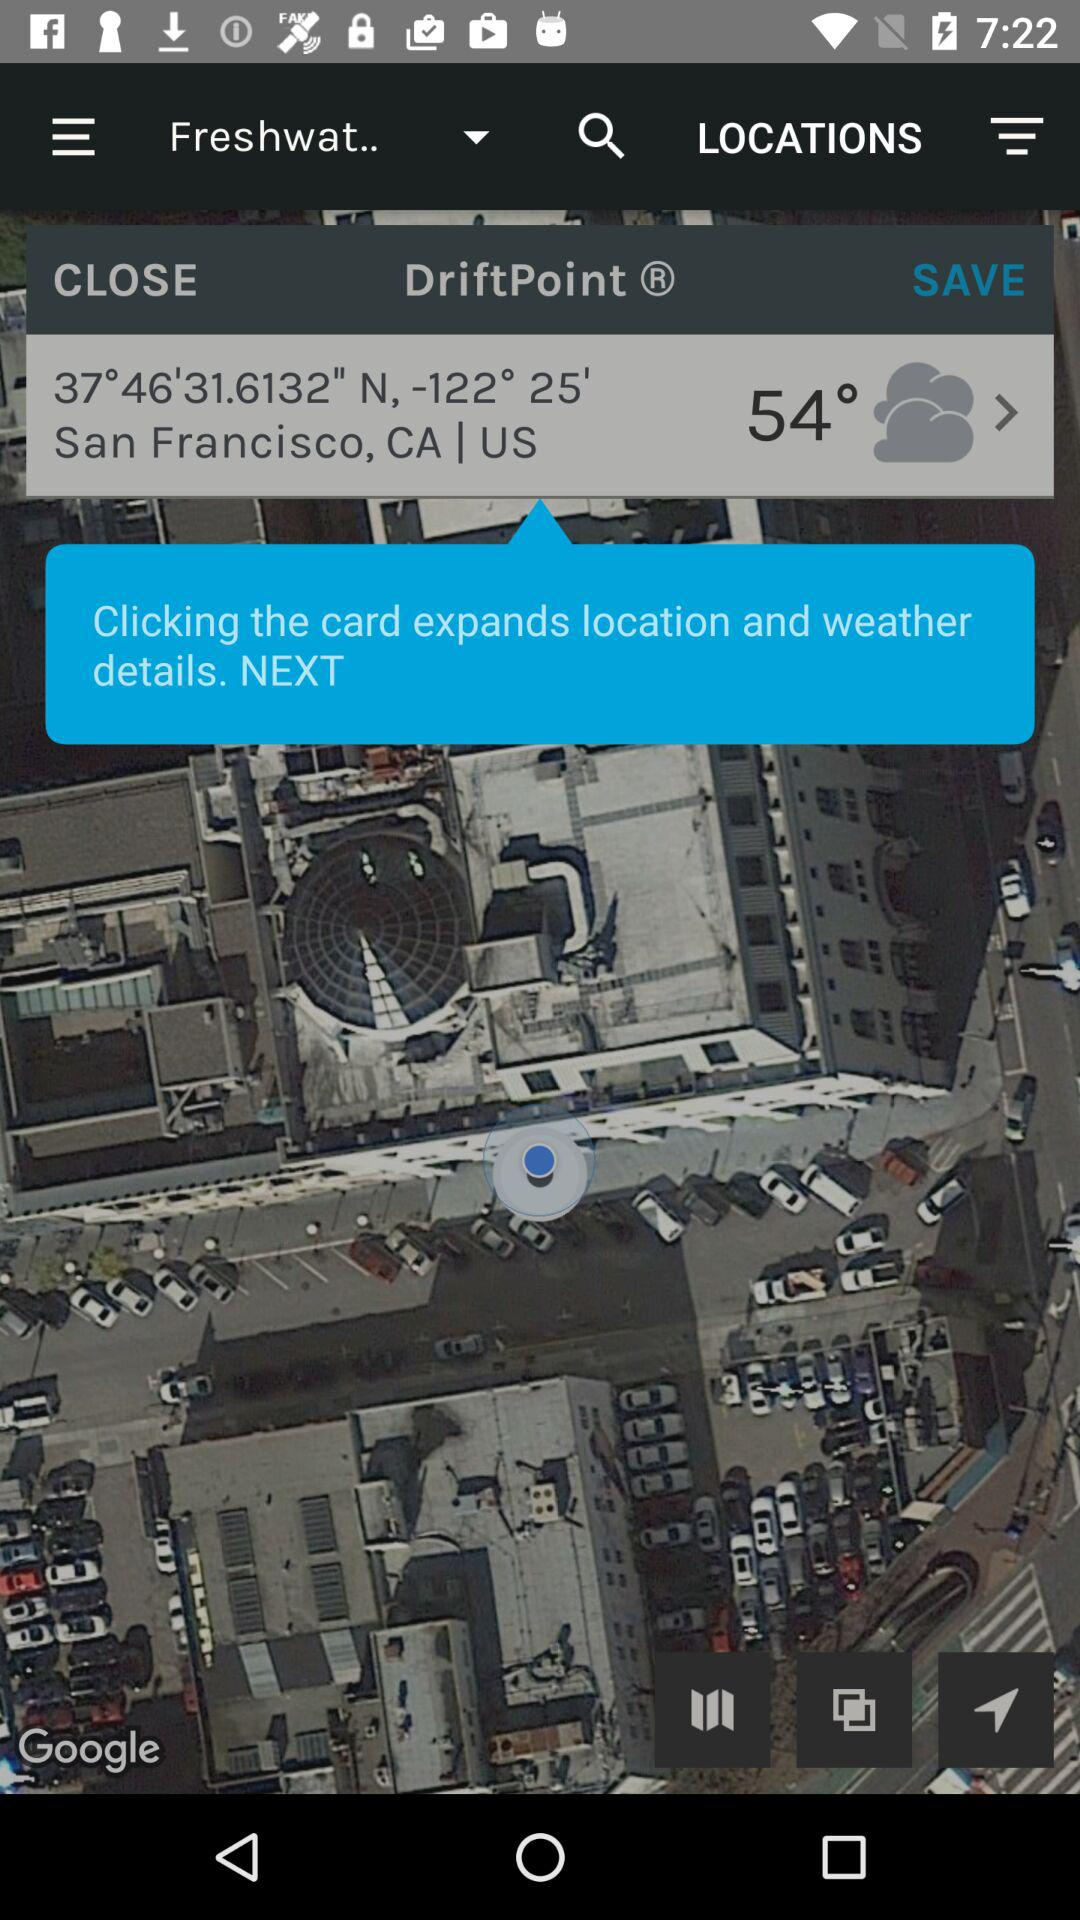What is the temperature? The temperature is 54°. 